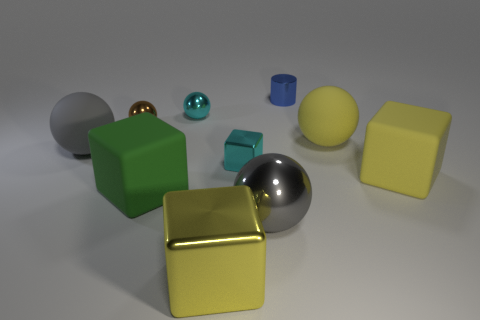There is a cylinder; are there any big gray shiny objects behind it? Upon observing the image, there are no large gray shiny objects located directly behind the cylinder. What we see instead are several geometric shapes with different characteristics positioned around the scene. 